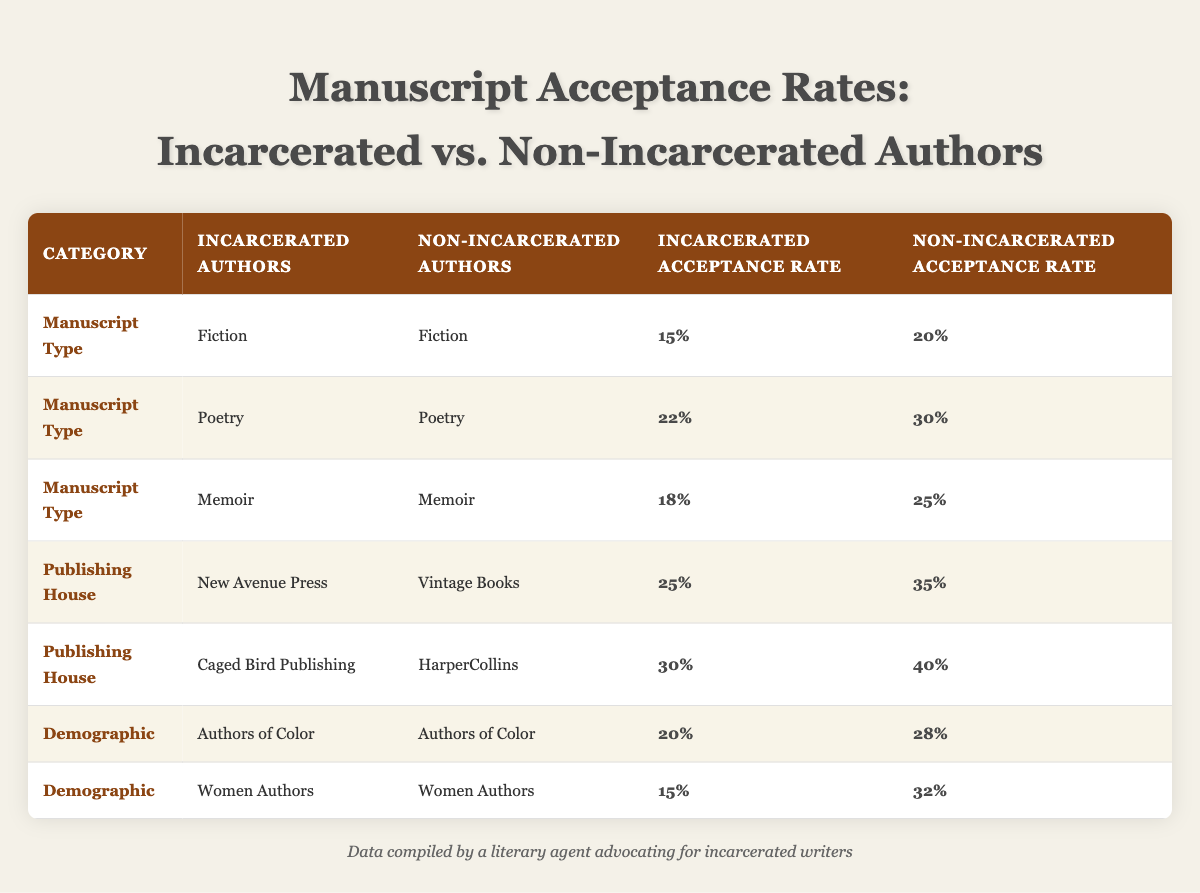What is the acceptance rate for incarcerated authors submitting poetry? The table shows that the acceptance rate for incarcerated authors submitting poetry is listed as 22%.
Answer: 22% What is the acceptance rate for non-incarcerated authors in memoirs? According to the table, the acceptance rate for non-incarcerated authors submitting memoirs is 25%.
Answer: 25% Which category has the highest acceptance rate for non-incarcerated authors? By comparing all provided rates for non-incarcerated authors, the highest rate is 40% for Caged Bird Publishing.
Answer: 40% What is the difference in acceptance rates between incarcerated and non-incarcerated authors for fiction? The acceptance rate for incarcerated authors in fiction is 15% and for non-incarcerated authors, it is 20%. The difference is 20% - 15% = 5%.
Answer: 5% Are the acceptance rates for incarcerated authors higher in poetry or memoirs? The acceptance rate for poetry is 22% and for memoirs, it is 18%. Since 22% is greater than 18%, poetry has the higher acceptance rate.
Answer: Poetry What is the average acceptance rate for incarcerated authors across all manuscript types listed in the table? Adding the acceptance rates for incarcerated authors: 15% (Fiction) + 22% (Poetry) + 18% (Memoir) = 55%. Dividing by the number of manuscript types (3): 55% / 3 = approximately 18.33%.
Answer: ~18.33% Is the acceptance rate for women authors higher among non-incarcerated or incarcerated authors? The acceptance rate for incarcerated women authors is 15%, while for non-incarcerated women authors it is 32%. Since 32% is higher than 15%, the non-incarcerated authors have a higher acceptance rate.
Answer: Non-incarcerated authors What percentage point difference exists between the acceptance rates of authors of color for incarcerated and non-incarcerated submissions? The acceptance rate for incarcerated authors of color is 20% and for non-incarcerated authors is 28%. The percentage point difference is 28% - 20% = 8%.
Answer: 8% What can be concluded about the acceptance rates for New Avenue Press compared to Vintage Books for incarcerated authors? New Avenue Press has an acceptance rate of 25% while Vintage Books has a higher acceptance rate of 35% for non-incarcerated authors. This suggests that incarcerated authors have a lower acceptance rate at New Avenue Press than non-incarcerated authors at Vintage Books.
Answer: Lower acceptance rate at New Avenue Press Which demographic, incarcerated or non-incarcerated, has a better acceptance rate for authors of color? The acceptance rate for incarcerated authors of color is 20%, while non-incarcerated authors of color have an acceptance rate of 28%. Since 28% is greater than 20%, non-incarcerated authors have a better acceptance rate.
Answer: Non-incarcerated authors 